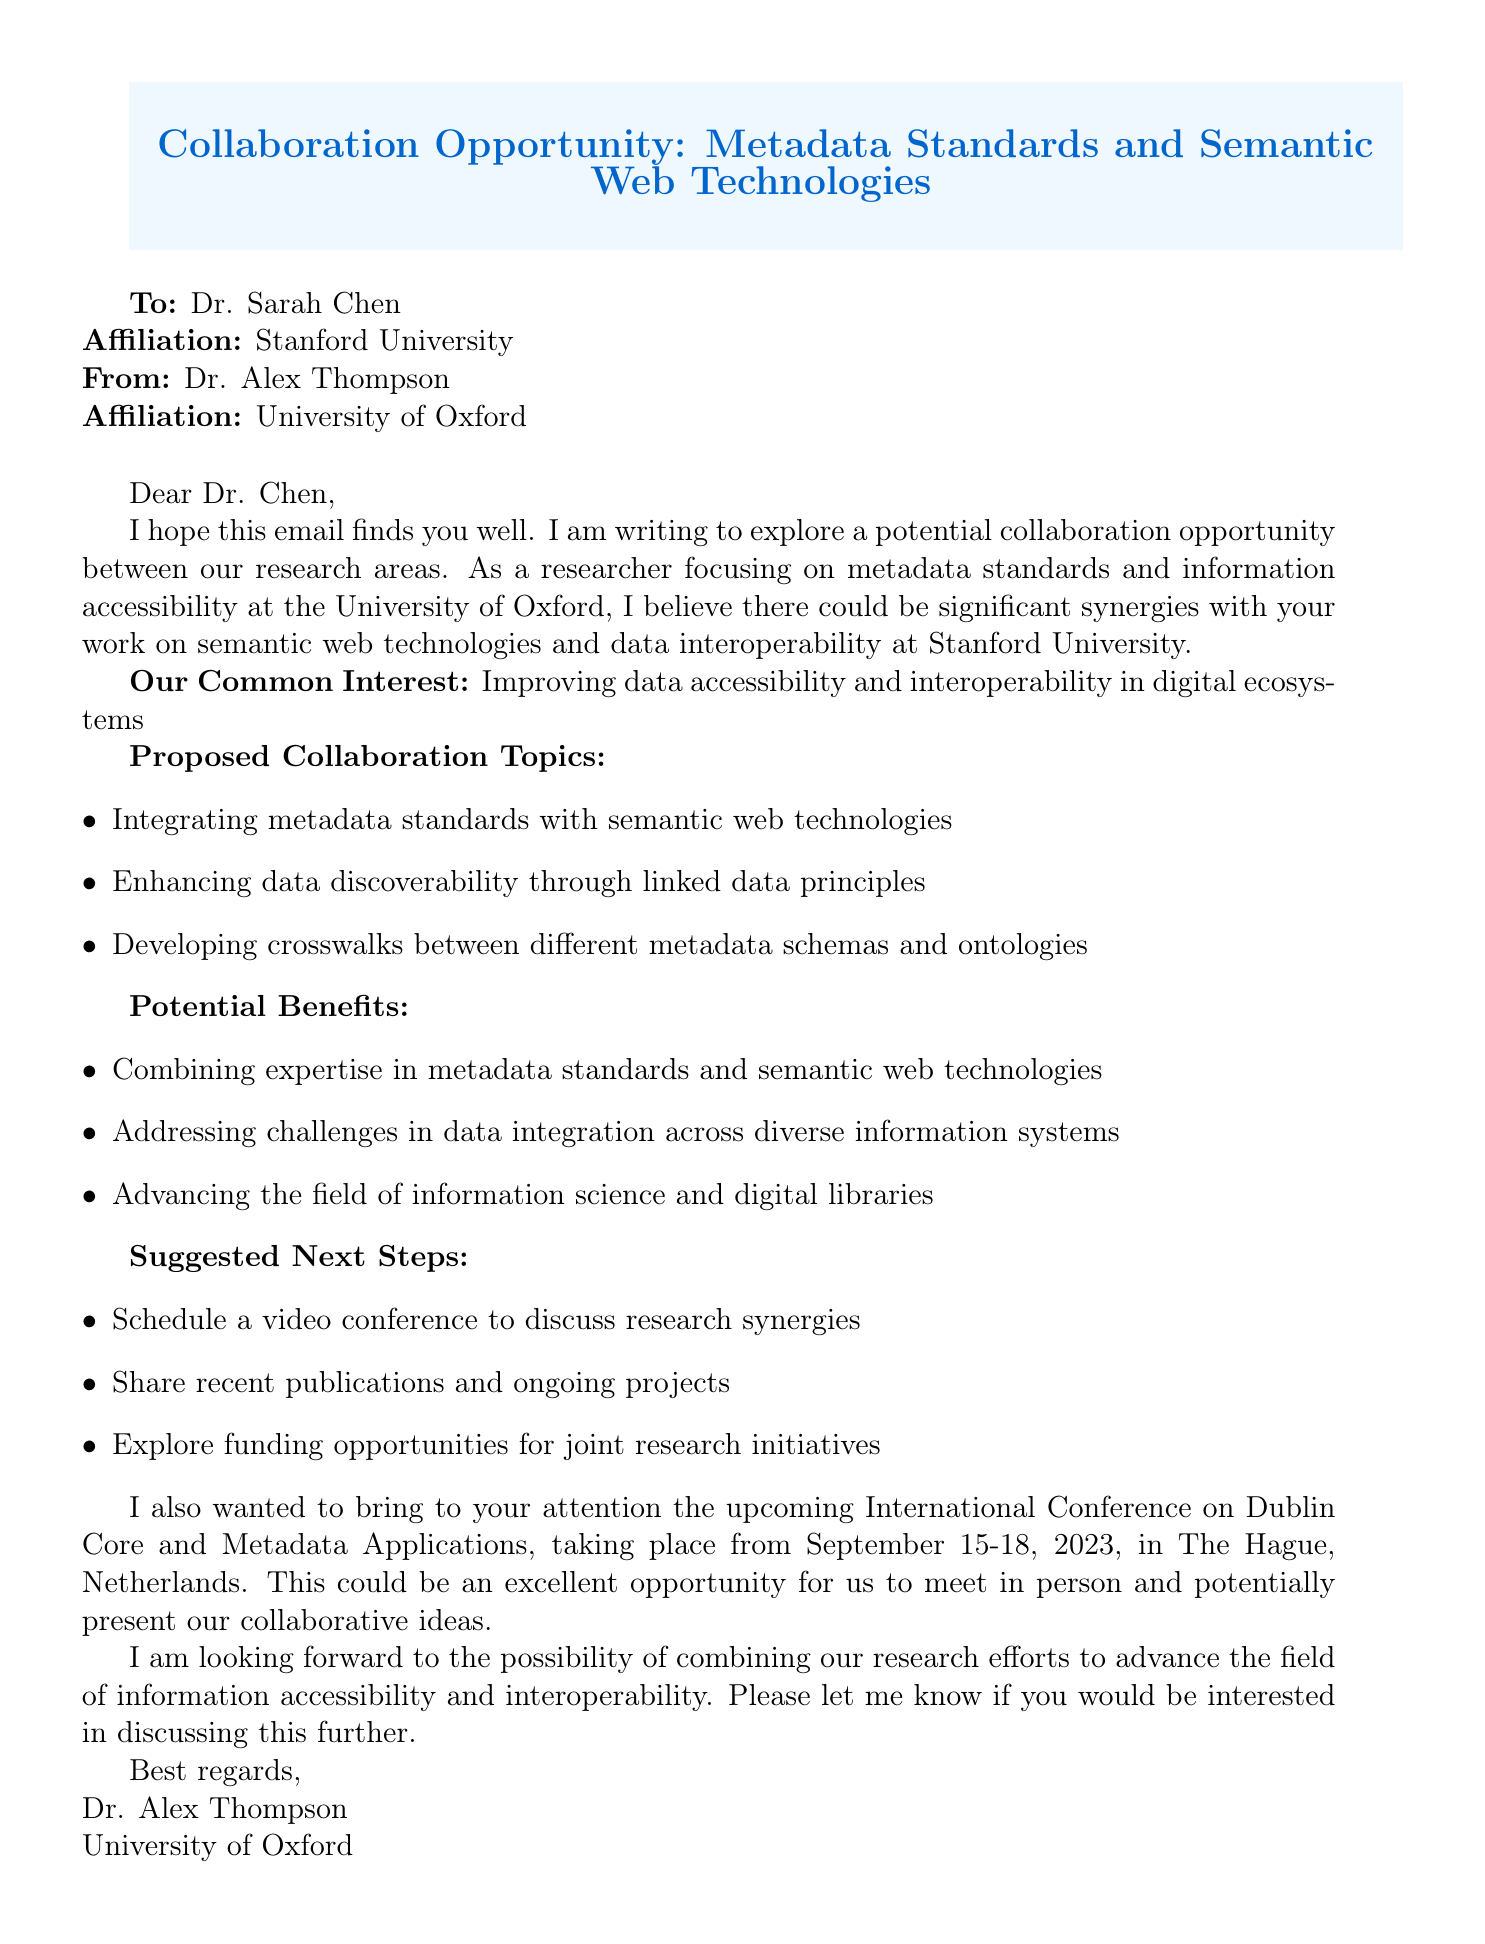What is the email subject? The subject of the email is stated at the beginning of the document.
Answer: Collaboration Opportunity: Metadata Standards and Semantic Web Technologies Who is the recipient of the email? The name of the recipient is mentioned right after the subject line.
Answer: Dr. Sarah Chen What is the proposed collaboration topic related to data discoverability? One of the proposed topics specifically mentions linked data principles.
Answer: Enhancing data discoverability through linked data principles What conference is mentioned in the email? The email highlights an upcoming conference relevant to the discussion.
Answer: International Conference on Dublin Core and Metadata Applications What are the suggested next steps? The email lists actions to take after the initial contact.
Answer: Schedule a video conference to discuss research synergies How many days will the mentioned conference take place? The dates of the conference indicated a multi-day event.
Answer: Four days What is the main goal of the collaboration? The email expresses a shared aim between the two researchers.
Answer: Improving data accessibility and interoperability in digital ecosystems What institution is Dr. Alex Thompson affiliated with? The sender's affiliation is provided in the email signature.
Answer: University of Oxford What is the date range of the conference? The dates are explicitly stated in the email.
Answer: September 15-18, 2023 